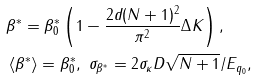Convert formula to latex. <formula><loc_0><loc_0><loc_500><loc_500>& \beta ^ { * } = \beta _ { 0 } ^ { * } \left ( 1 - \frac { 2 d ( N + 1 ) ^ { 2 } } { \pi ^ { 2 } } \Delta K \right ) , \\ & \left \langle \beta ^ { * } \right \rangle = \beta _ { 0 } ^ { * } , \ \sigma _ { \beta ^ { * } } = 2 \sigma _ { \kappa } D \sqrt { N + 1 } / E _ { q _ { 0 } } ,</formula> 